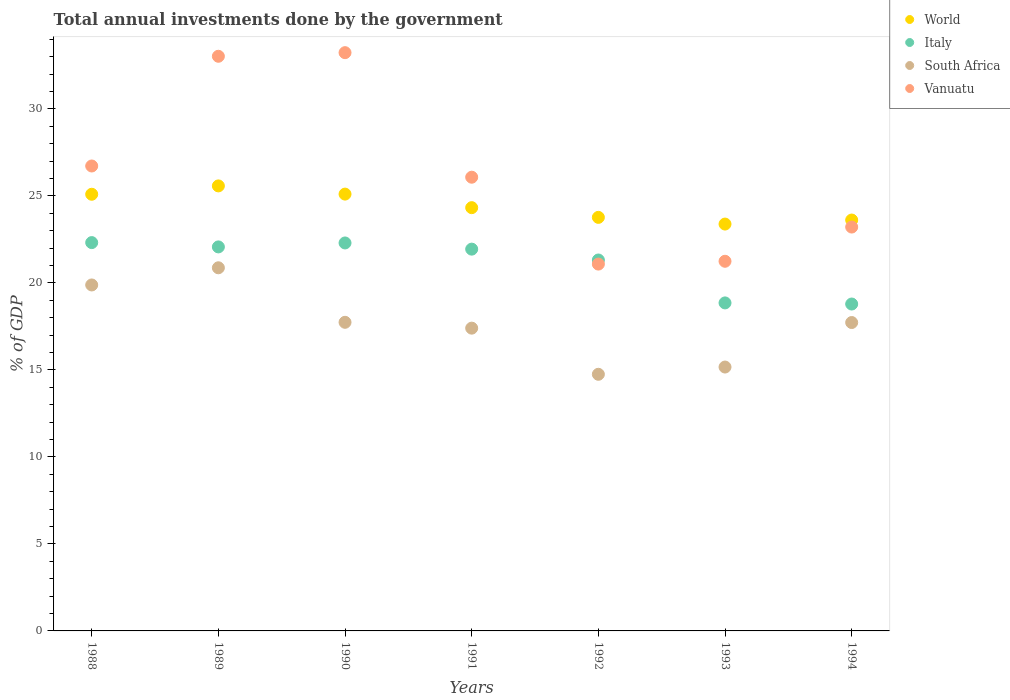How many different coloured dotlines are there?
Your response must be concise. 4. Is the number of dotlines equal to the number of legend labels?
Offer a terse response. Yes. What is the total annual investments done by the government in Vanuatu in 1990?
Provide a succinct answer. 33.23. Across all years, what is the maximum total annual investments done by the government in South Africa?
Give a very brief answer. 20.87. Across all years, what is the minimum total annual investments done by the government in Vanuatu?
Your answer should be compact. 21.08. In which year was the total annual investments done by the government in Italy maximum?
Offer a terse response. 1988. In which year was the total annual investments done by the government in World minimum?
Your answer should be very brief. 1993. What is the total total annual investments done by the government in Vanuatu in the graph?
Provide a succinct answer. 184.56. What is the difference between the total annual investments done by the government in South Africa in 1992 and that in 1993?
Your answer should be compact. -0.42. What is the difference between the total annual investments done by the government in Italy in 1991 and the total annual investments done by the government in World in 1989?
Provide a succinct answer. -3.63. What is the average total annual investments done by the government in Vanuatu per year?
Provide a succinct answer. 26.37. In the year 1990, what is the difference between the total annual investments done by the government in Vanuatu and total annual investments done by the government in South Africa?
Offer a very short reply. 15.49. In how many years, is the total annual investments done by the government in South Africa greater than 20 %?
Offer a very short reply. 1. What is the ratio of the total annual investments done by the government in South Africa in 1988 to that in 1990?
Keep it short and to the point. 1.12. What is the difference between the highest and the second highest total annual investments done by the government in World?
Your answer should be very brief. 0.47. What is the difference between the highest and the lowest total annual investments done by the government in Italy?
Your answer should be compact. 3.53. Is it the case that in every year, the sum of the total annual investments done by the government in Italy and total annual investments done by the government in South Africa  is greater than the sum of total annual investments done by the government in World and total annual investments done by the government in Vanuatu?
Provide a short and direct response. No. How many years are there in the graph?
Offer a very short reply. 7. Does the graph contain grids?
Your response must be concise. No. Where does the legend appear in the graph?
Provide a short and direct response. Top right. What is the title of the graph?
Ensure brevity in your answer.  Total annual investments done by the government. What is the label or title of the X-axis?
Ensure brevity in your answer.  Years. What is the label or title of the Y-axis?
Ensure brevity in your answer.  % of GDP. What is the % of GDP of World in 1988?
Offer a very short reply. 25.09. What is the % of GDP of Italy in 1988?
Ensure brevity in your answer.  22.31. What is the % of GDP in South Africa in 1988?
Your answer should be compact. 19.88. What is the % of GDP of Vanuatu in 1988?
Your answer should be very brief. 26.71. What is the % of GDP in World in 1989?
Give a very brief answer. 25.57. What is the % of GDP of Italy in 1989?
Ensure brevity in your answer.  22.07. What is the % of GDP in South Africa in 1989?
Offer a terse response. 20.87. What is the % of GDP of Vanuatu in 1989?
Provide a short and direct response. 33.02. What is the % of GDP of World in 1990?
Keep it short and to the point. 25.1. What is the % of GDP in Italy in 1990?
Provide a succinct answer. 22.29. What is the % of GDP in South Africa in 1990?
Your answer should be very brief. 17.73. What is the % of GDP of Vanuatu in 1990?
Make the answer very short. 33.23. What is the % of GDP in World in 1991?
Offer a terse response. 24.32. What is the % of GDP in Italy in 1991?
Make the answer very short. 21.94. What is the % of GDP of South Africa in 1991?
Your answer should be compact. 17.4. What is the % of GDP in Vanuatu in 1991?
Ensure brevity in your answer.  26.07. What is the % of GDP in World in 1992?
Your response must be concise. 23.76. What is the % of GDP of Italy in 1992?
Give a very brief answer. 21.31. What is the % of GDP in South Africa in 1992?
Ensure brevity in your answer.  14.75. What is the % of GDP in Vanuatu in 1992?
Offer a very short reply. 21.08. What is the % of GDP in World in 1993?
Give a very brief answer. 23.38. What is the % of GDP in Italy in 1993?
Provide a short and direct response. 18.85. What is the % of GDP of South Africa in 1993?
Make the answer very short. 15.16. What is the % of GDP of Vanuatu in 1993?
Your response must be concise. 21.24. What is the % of GDP in World in 1994?
Offer a very short reply. 23.61. What is the % of GDP in Italy in 1994?
Provide a short and direct response. 18.78. What is the % of GDP in South Africa in 1994?
Your answer should be very brief. 17.72. What is the % of GDP of Vanuatu in 1994?
Offer a very short reply. 23.21. Across all years, what is the maximum % of GDP in World?
Offer a terse response. 25.57. Across all years, what is the maximum % of GDP in Italy?
Your answer should be compact. 22.31. Across all years, what is the maximum % of GDP in South Africa?
Give a very brief answer. 20.87. Across all years, what is the maximum % of GDP of Vanuatu?
Your response must be concise. 33.23. Across all years, what is the minimum % of GDP of World?
Offer a terse response. 23.38. Across all years, what is the minimum % of GDP of Italy?
Ensure brevity in your answer.  18.78. Across all years, what is the minimum % of GDP in South Africa?
Offer a terse response. 14.75. Across all years, what is the minimum % of GDP in Vanuatu?
Make the answer very short. 21.08. What is the total % of GDP of World in the graph?
Offer a very short reply. 170.83. What is the total % of GDP of Italy in the graph?
Make the answer very short. 147.55. What is the total % of GDP in South Africa in the graph?
Make the answer very short. 123.5. What is the total % of GDP of Vanuatu in the graph?
Make the answer very short. 184.56. What is the difference between the % of GDP in World in 1988 and that in 1989?
Keep it short and to the point. -0.48. What is the difference between the % of GDP of Italy in 1988 and that in 1989?
Keep it short and to the point. 0.25. What is the difference between the % of GDP in South Africa in 1988 and that in 1989?
Give a very brief answer. -0.99. What is the difference between the % of GDP of Vanuatu in 1988 and that in 1989?
Your response must be concise. -6.3. What is the difference between the % of GDP of World in 1988 and that in 1990?
Give a very brief answer. -0.01. What is the difference between the % of GDP of Italy in 1988 and that in 1990?
Make the answer very short. 0.02. What is the difference between the % of GDP in South Africa in 1988 and that in 1990?
Your answer should be compact. 2.15. What is the difference between the % of GDP in Vanuatu in 1988 and that in 1990?
Ensure brevity in your answer.  -6.51. What is the difference between the % of GDP of World in 1988 and that in 1991?
Provide a succinct answer. 0.77. What is the difference between the % of GDP of Italy in 1988 and that in 1991?
Provide a succinct answer. 0.38. What is the difference between the % of GDP of South Africa in 1988 and that in 1991?
Provide a succinct answer. 2.48. What is the difference between the % of GDP in Vanuatu in 1988 and that in 1991?
Provide a short and direct response. 0.64. What is the difference between the % of GDP of World in 1988 and that in 1992?
Offer a terse response. 1.33. What is the difference between the % of GDP of South Africa in 1988 and that in 1992?
Make the answer very short. 5.13. What is the difference between the % of GDP of Vanuatu in 1988 and that in 1992?
Make the answer very short. 5.64. What is the difference between the % of GDP in World in 1988 and that in 1993?
Provide a succinct answer. 1.71. What is the difference between the % of GDP in Italy in 1988 and that in 1993?
Your answer should be very brief. 3.47. What is the difference between the % of GDP in South Africa in 1988 and that in 1993?
Your answer should be compact. 4.72. What is the difference between the % of GDP in Vanuatu in 1988 and that in 1993?
Offer a very short reply. 5.47. What is the difference between the % of GDP in World in 1988 and that in 1994?
Keep it short and to the point. 1.48. What is the difference between the % of GDP of Italy in 1988 and that in 1994?
Keep it short and to the point. 3.53. What is the difference between the % of GDP of South Africa in 1988 and that in 1994?
Make the answer very short. 2.16. What is the difference between the % of GDP in Vanuatu in 1988 and that in 1994?
Make the answer very short. 3.51. What is the difference between the % of GDP in World in 1989 and that in 1990?
Give a very brief answer. 0.47. What is the difference between the % of GDP of Italy in 1989 and that in 1990?
Keep it short and to the point. -0.23. What is the difference between the % of GDP of South Africa in 1989 and that in 1990?
Your response must be concise. 3.13. What is the difference between the % of GDP of Vanuatu in 1989 and that in 1990?
Give a very brief answer. -0.21. What is the difference between the % of GDP in World in 1989 and that in 1991?
Keep it short and to the point. 1.25. What is the difference between the % of GDP in Italy in 1989 and that in 1991?
Offer a terse response. 0.13. What is the difference between the % of GDP of South Africa in 1989 and that in 1991?
Keep it short and to the point. 3.47. What is the difference between the % of GDP in Vanuatu in 1989 and that in 1991?
Provide a short and direct response. 6.95. What is the difference between the % of GDP of World in 1989 and that in 1992?
Your response must be concise. 1.81. What is the difference between the % of GDP in Italy in 1989 and that in 1992?
Provide a short and direct response. 0.75. What is the difference between the % of GDP of South Africa in 1989 and that in 1992?
Your answer should be very brief. 6.12. What is the difference between the % of GDP in Vanuatu in 1989 and that in 1992?
Your response must be concise. 11.94. What is the difference between the % of GDP in World in 1989 and that in 1993?
Offer a terse response. 2.19. What is the difference between the % of GDP in Italy in 1989 and that in 1993?
Your answer should be compact. 3.22. What is the difference between the % of GDP of South Africa in 1989 and that in 1993?
Your answer should be compact. 5.7. What is the difference between the % of GDP of Vanuatu in 1989 and that in 1993?
Your answer should be compact. 11.78. What is the difference between the % of GDP of World in 1989 and that in 1994?
Make the answer very short. 1.96. What is the difference between the % of GDP in Italy in 1989 and that in 1994?
Your answer should be compact. 3.28. What is the difference between the % of GDP in South Africa in 1989 and that in 1994?
Your answer should be very brief. 3.15. What is the difference between the % of GDP in Vanuatu in 1989 and that in 1994?
Provide a succinct answer. 9.81. What is the difference between the % of GDP in World in 1990 and that in 1991?
Provide a succinct answer. 0.78. What is the difference between the % of GDP in Italy in 1990 and that in 1991?
Your answer should be compact. 0.36. What is the difference between the % of GDP in South Africa in 1990 and that in 1991?
Offer a very short reply. 0.34. What is the difference between the % of GDP in Vanuatu in 1990 and that in 1991?
Your answer should be compact. 7.16. What is the difference between the % of GDP in World in 1990 and that in 1992?
Your answer should be very brief. 1.34. What is the difference between the % of GDP of Italy in 1990 and that in 1992?
Make the answer very short. 0.98. What is the difference between the % of GDP in South Africa in 1990 and that in 1992?
Provide a short and direct response. 2.99. What is the difference between the % of GDP in Vanuatu in 1990 and that in 1992?
Your response must be concise. 12.15. What is the difference between the % of GDP of World in 1990 and that in 1993?
Provide a short and direct response. 1.72. What is the difference between the % of GDP in Italy in 1990 and that in 1993?
Provide a short and direct response. 3.44. What is the difference between the % of GDP in South Africa in 1990 and that in 1993?
Your answer should be very brief. 2.57. What is the difference between the % of GDP of Vanuatu in 1990 and that in 1993?
Ensure brevity in your answer.  11.99. What is the difference between the % of GDP in World in 1990 and that in 1994?
Give a very brief answer. 1.49. What is the difference between the % of GDP in Italy in 1990 and that in 1994?
Provide a short and direct response. 3.51. What is the difference between the % of GDP in South Africa in 1990 and that in 1994?
Your answer should be compact. 0.01. What is the difference between the % of GDP in Vanuatu in 1990 and that in 1994?
Offer a terse response. 10.02. What is the difference between the % of GDP in World in 1991 and that in 1992?
Ensure brevity in your answer.  0.56. What is the difference between the % of GDP in Italy in 1991 and that in 1992?
Offer a very short reply. 0.62. What is the difference between the % of GDP in South Africa in 1991 and that in 1992?
Offer a very short reply. 2.65. What is the difference between the % of GDP of Vanuatu in 1991 and that in 1992?
Provide a succinct answer. 4.99. What is the difference between the % of GDP of World in 1991 and that in 1993?
Provide a succinct answer. 0.94. What is the difference between the % of GDP in Italy in 1991 and that in 1993?
Keep it short and to the point. 3.09. What is the difference between the % of GDP in South Africa in 1991 and that in 1993?
Make the answer very short. 2.23. What is the difference between the % of GDP of Vanuatu in 1991 and that in 1993?
Make the answer very short. 4.83. What is the difference between the % of GDP in World in 1991 and that in 1994?
Keep it short and to the point. 0.71. What is the difference between the % of GDP of Italy in 1991 and that in 1994?
Your answer should be very brief. 3.15. What is the difference between the % of GDP of South Africa in 1991 and that in 1994?
Your answer should be compact. -0.32. What is the difference between the % of GDP of Vanuatu in 1991 and that in 1994?
Give a very brief answer. 2.86. What is the difference between the % of GDP of World in 1992 and that in 1993?
Ensure brevity in your answer.  0.38. What is the difference between the % of GDP of Italy in 1992 and that in 1993?
Your answer should be compact. 2.47. What is the difference between the % of GDP in South Africa in 1992 and that in 1993?
Offer a terse response. -0.42. What is the difference between the % of GDP in Vanuatu in 1992 and that in 1993?
Give a very brief answer. -0.16. What is the difference between the % of GDP in World in 1992 and that in 1994?
Your response must be concise. 0.15. What is the difference between the % of GDP of Italy in 1992 and that in 1994?
Make the answer very short. 2.53. What is the difference between the % of GDP of South Africa in 1992 and that in 1994?
Provide a short and direct response. -2.97. What is the difference between the % of GDP in Vanuatu in 1992 and that in 1994?
Your answer should be compact. -2.13. What is the difference between the % of GDP in World in 1993 and that in 1994?
Offer a terse response. -0.23. What is the difference between the % of GDP in Italy in 1993 and that in 1994?
Your answer should be compact. 0.06. What is the difference between the % of GDP of South Africa in 1993 and that in 1994?
Provide a short and direct response. -2.56. What is the difference between the % of GDP in Vanuatu in 1993 and that in 1994?
Your answer should be compact. -1.97. What is the difference between the % of GDP in World in 1988 and the % of GDP in Italy in 1989?
Make the answer very short. 3.03. What is the difference between the % of GDP in World in 1988 and the % of GDP in South Africa in 1989?
Give a very brief answer. 4.22. What is the difference between the % of GDP in World in 1988 and the % of GDP in Vanuatu in 1989?
Offer a very short reply. -7.93. What is the difference between the % of GDP in Italy in 1988 and the % of GDP in South Africa in 1989?
Your answer should be very brief. 1.45. What is the difference between the % of GDP in Italy in 1988 and the % of GDP in Vanuatu in 1989?
Your answer should be compact. -10.71. What is the difference between the % of GDP in South Africa in 1988 and the % of GDP in Vanuatu in 1989?
Your answer should be very brief. -13.14. What is the difference between the % of GDP of World in 1988 and the % of GDP of Italy in 1990?
Offer a very short reply. 2.8. What is the difference between the % of GDP in World in 1988 and the % of GDP in South Africa in 1990?
Provide a short and direct response. 7.36. What is the difference between the % of GDP in World in 1988 and the % of GDP in Vanuatu in 1990?
Provide a succinct answer. -8.14. What is the difference between the % of GDP in Italy in 1988 and the % of GDP in South Africa in 1990?
Keep it short and to the point. 4.58. What is the difference between the % of GDP in Italy in 1988 and the % of GDP in Vanuatu in 1990?
Keep it short and to the point. -10.91. What is the difference between the % of GDP in South Africa in 1988 and the % of GDP in Vanuatu in 1990?
Give a very brief answer. -13.35. What is the difference between the % of GDP of World in 1988 and the % of GDP of Italy in 1991?
Ensure brevity in your answer.  3.15. What is the difference between the % of GDP in World in 1988 and the % of GDP in South Africa in 1991?
Give a very brief answer. 7.69. What is the difference between the % of GDP in World in 1988 and the % of GDP in Vanuatu in 1991?
Offer a terse response. -0.98. What is the difference between the % of GDP in Italy in 1988 and the % of GDP in South Africa in 1991?
Offer a terse response. 4.92. What is the difference between the % of GDP of Italy in 1988 and the % of GDP of Vanuatu in 1991?
Provide a short and direct response. -3.76. What is the difference between the % of GDP of South Africa in 1988 and the % of GDP of Vanuatu in 1991?
Your answer should be compact. -6.19. What is the difference between the % of GDP of World in 1988 and the % of GDP of Italy in 1992?
Make the answer very short. 3.78. What is the difference between the % of GDP of World in 1988 and the % of GDP of South Africa in 1992?
Your answer should be very brief. 10.34. What is the difference between the % of GDP of World in 1988 and the % of GDP of Vanuatu in 1992?
Your answer should be compact. 4.01. What is the difference between the % of GDP of Italy in 1988 and the % of GDP of South Africa in 1992?
Your answer should be very brief. 7.57. What is the difference between the % of GDP in Italy in 1988 and the % of GDP in Vanuatu in 1992?
Keep it short and to the point. 1.23. What is the difference between the % of GDP in South Africa in 1988 and the % of GDP in Vanuatu in 1992?
Ensure brevity in your answer.  -1.2. What is the difference between the % of GDP of World in 1988 and the % of GDP of Italy in 1993?
Provide a succinct answer. 6.24. What is the difference between the % of GDP of World in 1988 and the % of GDP of South Africa in 1993?
Your answer should be compact. 9.93. What is the difference between the % of GDP of World in 1988 and the % of GDP of Vanuatu in 1993?
Give a very brief answer. 3.85. What is the difference between the % of GDP in Italy in 1988 and the % of GDP in South Africa in 1993?
Keep it short and to the point. 7.15. What is the difference between the % of GDP in Italy in 1988 and the % of GDP in Vanuatu in 1993?
Offer a very short reply. 1.07. What is the difference between the % of GDP in South Africa in 1988 and the % of GDP in Vanuatu in 1993?
Your answer should be very brief. -1.36. What is the difference between the % of GDP in World in 1988 and the % of GDP in Italy in 1994?
Offer a very short reply. 6.31. What is the difference between the % of GDP of World in 1988 and the % of GDP of South Africa in 1994?
Offer a very short reply. 7.37. What is the difference between the % of GDP in World in 1988 and the % of GDP in Vanuatu in 1994?
Keep it short and to the point. 1.88. What is the difference between the % of GDP in Italy in 1988 and the % of GDP in South Africa in 1994?
Provide a succinct answer. 4.59. What is the difference between the % of GDP of Italy in 1988 and the % of GDP of Vanuatu in 1994?
Make the answer very short. -0.89. What is the difference between the % of GDP in South Africa in 1988 and the % of GDP in Vanuatu in 1994?
Provide a succinct answer. -3.33. What is the difference between the % of GDP in World in 1989 and the % of GDP in Italy in 1990?
Keep it short and to the point. 3.28. What is the difference between the % of GDP of World in 1989 and the % of GDP of South Africa in 1990?
Offer a terse response. 7.84. What is the difference between the % of GDP in World in 1989 and the % of GDP in Vanuatu in 1990?
Offer a terse response. -7.66. What is the difference between the % of GDP in Italy in 1989 and the % of GDP in South Africa in 1990?
Give a very brief answer. 4.33. What is the difference between the % of GDP in Italy in 1989 and the % of GDP in Vanuatu in 1990?
Your response must be concise. -11.16. What is the difference between the % of GDP of South Africa in 1989 and the % of GDP of Vanuatu in 1990?
Give a very brief answer. -12.36. What is the difference between the % of GDP of World in 1989 and the % of GDP of Italy in 1991?
Offer a terse response. 3.63. What is the difference between the % of GDP in World in 1989 and the % of GDP in South Africa in 1991?
Make the answer very short. 8.17. What is the difference between the % of GDP of World in 1989 and the % of GDP of Vanuatu in 1991?
Make the answer very short. -0.5. What is the difference between the % of GDP in Italy in 1989 and the % of GDP in South Africa in 1991?
Provide a short and direct response. 4.67. What is the difference between the % of GDP in Italy in 1989 and the % of GDP in Vanuatu in 1991?
Your answer should be compact. -4. What is the difference between the % of GDP of South Africa in 1989 and the % of GDP of Vanuatu in 1991?
Offer a very short reply. -5.2. What is the difference between the % of GDP in World in 1989 and the % of GDP in Italy in 1992?
Your answer should be very brief. 4.26. What is the difference between the % of GDP in World in 1989 and the % of GDP in South Africa in 1992?
Ensure brevity in your answer.  10.82. What is the difference between the % of GDP in World in 1989 and the % of GDP in Vanuatu in 1992?
Provide a short and direct response. 4.49. What is the difference between the % of GDP in Italy in 1989 and the % of GDP in South Africa in 1992?
Your answer should be compact. 7.32. What is the difference between the % of GDP of Italy in 1989 and the % of GDP of Vanuatu in 1992?
Make the answer very short. 0.99. What is the difference between the % of GDP in South Africa in 1989 and the % of GDP in Vanuatu in 1992?
Keep it short and to the point. -0.21. What is the difference between the % of GDP in World in 1989 and the % of GDP in Italy in 1993?
Your answer should be compact. 6.72. What is the difference between the % of GDP of World in 1989 and the % of GDP of South Africa in 1993?
Offer a terse response. 10.41. What is the difference between the % of GDP of World in 1989 and the % of GDP of Vanuatu in 1993?
Your response must be concise. 4.33. What is the difference between the % of GDP in Italy in 1989 and the % of GDP in South Africa in 1993?
Provide a succinct answer. 6.9. What is the difference between the % of GDP in Italy in 1989 and the % of GDP in Vanuatu in 1993?
Ensure brevity in your answer.  0.83. What is the difference between the % of GDP in South Africa in 1989 and the % of GDP in Vanuatu in 1993?
Provide a short and direct response. -0.37. What is the difference between the % of GDP in World in 1989 and the % of GDP in Italy in 1994?
Provide a succinct answer. 6.79. What is the difference between the % of GDP of World in 1989 and the % of GDP of South Africa in 1994?
Offer a terse response. 7.85. What is the difference between the % of GDP of World in 1989 and the % of GDP of Vanuatu in 1994?
Keep it short and to the point. 2.36. What is the difference between the % of GDP in Italy in 1989 and the % of GDP in South Africa in 1994?
Provide a succinct answer. 4.35. What is the difference between the % of GDP in Italy in 1989 and the % of GDP in Vanuatu in 1994?
Provide a succinct answer. -1.14. What is the difference between the % of GDP of South Africa in 1989 and the % of GDP of Vanuatu in 1994?
Keep it short and to the point. -2.34. What is the difference between the % of GDP in World in 1990 and the % of GDP in Italy in 1991?
Keep it short and to the point. 3.16. What is the difference between the % of GDP of World in 1990 and the % of GDP of South Africa in 1991?
Offer a very short reply. 7.7. What is the difference between the % of GDP of World in 1990 and the % of GDP of Vanuatu in 1991?
Your response must be concise. -0.97. What is the difference between the % of GDP in Italy in 1990 and the % of GDP in South Africa in 1991?
Keep it short and to the point. 4.9. What is the difference between the % of GDP in Italy in 1990 and the % of GDP in Vanuatu in 1991?
Make the answer very short. -3.78. What is the difference between the % of GDP of South Africa in 1990 and the % of GDP of Vanuatu in 1991?
Provide a short and direct response. -8.34. What is the difference between the % of GDP in World in 1990 and the % of GDP in Italy in 1992?
Your answer should be compact. 3.79. What is the difference between the % of GDP in World in 1990 and the % of GDP in South Africa in 1992?
Ensure brevity in your answer.  10.35. What is the difference between the % of GDP of World in 1990 and the % of GDP of Vanuatu in 1992?
Ensure brevity in your answer.  4.02. What is the difference between the % of GDP of Italy in 1990 and the % of GDP of South Africa in 1992?
Give a very brief answer. 7.55. What is the difference between the % of GDP of Italy in 1990 and the % of GDP of Vanuatu in 1992?
Make the answer very short. 1.21. What is the difference between the % of GDP in South Africa in 1990 and the % of GDP in Vanuatu in 1992?
Offer a terse response. -3.35. What is the difference between the % of GDP in World in 1990 and the % of GDP in Italy in 1993?
Offer a terse response. 6.25. What is the difference between the % of GDP of World in 1990 and the % of GDP of South Africa in 1993?
Provide a succinct answer. 9.94. What is the difference between the % of GDP of World in 1990 and the % of GDP of Vanuatu in 1993?
Make the answer very short. 3.86. What is the difference between the % of GDP of Italy in 1990 and the % of GDP of South Africa in 1993?
Ensure brevity in your answer.  7.13. What is the difference between the % of GDP in Italy in 1990 and the % of GDP in Vanuatu in 1993?
Offer a terse response. 1.05. What is the difference between the % of GDP of South Africa in 1990 and the % of GDP of Vanuatu in 1993?
Your response must be concise. -3.51. What is the difference between the % of GDP in World in 1990 and the % of GDP in Italy in 1994?
Offer a terse response. 6.32. What is the difference between the % of GDP of World in 1990 and the % of GDP of South Africa in 1994?
Make the answer very short. 7.38. What is the difference between the % of GDP in World in 1990 and the % of GDP in Vanuatu in 1994?
Give a very brief answer. 1.89. What is the difference between the % of GDP in Italy in 1990 and the % of GDP in South Africa in 1994?
Keep it short and to the point. 4.57. What is the difference between the % of GDP in Italy in 1990 and the % of GDP in Vanuatu in 1994?
Keep it short and to the point. -0.91. What is the difference between the % of GDP in South Africa in 1990 and the % of GDP in Vanuatu in 1994?
Your answer should be very brief. -5.47. What is the difference between the % of GDP of World in 1991 and the % of GDP of Italy in 1992?
Offer a terse response. 3.01. What is the difference between the % of GDP of World in 1991 and the % of GDP of South Africa in 1992?
Keep it short and to the point. 9.57. What is the difference between the % of GDP of World in 1991 and the % of GDP of Vanuatu in 1992?
Offer a terse response. 3.24. What is the difference between the % of GDP of Italy in 1991 and the % of GDP of South Africa in 1992?
Ensure brevity in your answer.  7.19. What is the difference between the % of GDP of Italy in 1991 and the % of GDP of Vanuatu in 1992?
Your answer should be very brief. 0.86. What is the difference between the % of GDP of South Africa in 1991 and the % of GDP of Vanuatu in 1992?
Your answer should be very brief. -3.68. What is the difference between the % of GDP in World in 1991 and the % of GDP in Italy in 1993?
Ensure brevity in your answer.  5.47. What is the difference between the % of GDP in World in 1991 and the % of GDP in South Africa in 1993?
Provide a succinct answer. 9.16. What is the difference between the % of GDP of World in 1991 and the % of GDP of Vanuatu in 1993?
Your answer should be very brief. 3.08. What is the difference between the % of GDP in Italy in 1991 and the % of GDP in South Africa in 1993?
Your answer should be compact. 6.78. What is the difference between the % of GDP of Italy in 1991 and the % of GDP of Vanuatu in 1993?
Your answer should be compact. 0.7. What is the difference between the % of GDP in South Africa in 1991 and the % of GDP in Vanuatu in 1993?
Offer a terse response. -3.84. What is the difference between the % of GDP in World in 1991 and the % of GDP in Italy in 1994?
Your answer should be compact. 5.54. What is the difference between the % of GDP in World in 1991 and the % of GDP in South Africa in 1994?
Your response must be concise. 6.6. What is the difference between the % of GDP in World in 1991 and the % of GDP in Vanuatu in 1994?
Give a very brief answer. 1.11. What is the difference between the % of GDP in Italy in 1991 and the % of GDP in South Africa in 1994?
Offer a terse response. 4.22. What is the difference between the % of GDP in Italy in 1991 and the % of GDP in Vanuatu in 1994?
Give a very brief answer. -1.27. What is the difference between the % of GDP in South Africa in 1991 and the % of GDP in Vanuatu in 1994?
Ensure brevity in your answer.  -5.81. What is the difference between the % of GDP in World in 1992 and the % of GDP in Italy in 1993?
Your answer should be compact. 4.92. What is the difference between the % of GDP in World in 1992 and the % of GDP in South Africa in 1993?
Make the answer very short. 8.6. What is the difference between the % of GDP in World in 1992 and the % of GDP in Vanuatu in 1993?
Your response must be concise. 2.52. What is the difference between the % of GDP of Italy in 1992 and the % of GDP of South Africa in 1993?
Provide a succinct answer. 6.15. What is the difference between the % of GDP of Italy in 1992 and the % of GDP of Vanuatu in 1993?
Your response must be concise. 0.07. What is the difference between the % of GDP in South Africa in 1992 and the % of GDP in Vanuatu in 1993?
Your response must be concise. -6.49. What is the difference between the % of GDP in World in 1992 and the % of GDP in Italy in 1994?
Your response must be concise. 4.98. What is the difference between the % of GDP in World in 1992 and the % of GDP in South Africa in 1994?
Offer a very short reply. 6.04. What is the difference between the % of GDP in World in 1992 and the % of GDP in Vanuatu in 1994?
Your response must be concise. 0.56. What is the difference between the % of GDP of Italy in 1992 and the % of GDP of South Africa in 1994?
Ensure brevity in your answer.  3.59. What is the difference between the % of GDP of Italy in 1992 and the % of GDP of Vanuatu in 1994?
Your answer should be very brief. -1.89. What is the difference between the % of GDP in South Africa in 1992 and the % of GDP in Vanuatu in 1994?
Make the answer very short. -8.46. What is the difference between the % of GDP of World in 1993 and the % of GDP of Italy in 1994?
Ensure brevity in your answer.  4.59. What is the difference between the % of GDP of World in 1993 and the % of GDP of South Africa in 1994?
Provide a succinct answer. 5.66. What is the difference between the % of GDP in World in 1993 and the % of GDP in Vanuatu in 1994?
Keep it short and to the point. 0.17. What is the difference between the % of GDP of Italy in 1993 and the % of GDP of South Africa in 1994?
Provide a short and direct response. 1.13. What is the difference between the % of GDP of Italy in 1993 and the % of GDP of Vanuatu in 1994?
Offer a very short reply. -4.36. What is the difference between the % of GDP of South Africa in 1993 and the % of GDP of Vanuatu in 1994?
Offer a terse response. -8.04. What is the average % of GDP of World per year?
Your answer should be very brief. 24.4. What is the average % of GDP in Italy per year?
Make the answer very short. 21.08. What is the average % of GDP of South Africa per year?
Your answer should be compact. 17.64. What is the average % of GDP in Vanuatu per year?
Provide a succinct answer. 26.37. In the year 1988, what is the difference between the % of GDP of World and % of GDP of Italy?
Make the answer very short. 2.78. In the year 1988, what is the difference between the % of GDP of World and % of GDP of South Africa?
Offer a terse response. 5.21. In the year 1988, what is the difference between the % of GDP in World and % of GDP in Vanuatu?
Offer a very short reply. -1.62. In the year 1988, what is the difference between the % of GDP of Italy and % of GDP of South Africa?
Offer a terse response. 2.43. In the year 1988, what is the difference between the % of GDP of Italy and % of GDP of Vanuatu?
Offer a terse response. -4.4. In the year 1988, what is the difference between the % of GDP of South Africa and % of GDP of Vanuatu?
Give a very brief answer. -6.84. In the year 1989, what is the difference between the % of GDP of World and % of GDP of Italy?
Your answer should be compact. 3.51. In the year 1989, what is the difference between the % of GDP in World and % of GDP in South Africa?
Give a very brief answer. 4.71. In the year 1989, what is the difference between the % of GDP in World and % of GDP in Vanuatu?
Offer a terse response. -7.45. In the year 1989, what is the difference between the % of GDP of Italy and % of GDP of South Africa?
Keep it short and to the point. 1.2. In the year 1989, what is the difference between the % of GDP of Italy and % of GDP of Vanuatu?
Your answer should be very brief. -10.95. In the year 1989, what is the difference between the % of GDP of South Africa and % of GDP of Vanuatu?
Offer a terse response. -12.15. In the year 1990, what is the difference between the % of GDP of World and % of GDP of Italy?
Keep it short and to the point. 2.81. In the year 1990, what is the difference between the % of GDP in World and % of GDP in South Africa?
Keep it short and to the point. 7.37. In the year 1990, what is the difference between the % of GDP of World and % of GDP of Vanuatu?
Offer a terse response. -8.13. In the year 1990, what is the difference between the % of GDP in Italy and % of GDP in South Africa?
Your response must be concise. 4.56. In the year 1990, what is the difference between the % of GDP in Italy and % of GDP in Vanuatu?
Offer a terse response. -10.93. In the year 1990, what is the difference between the % of GDP of South Africa and % of GDP of Vanuatu?
Your answer should be very brief. -15.49. In the year 1991, what is the difference between the % of GDP of World and % of GDP of Italy?
Make the answer very short. 2.38. In the year 1991, what is the difference between the % of GDP in World and % of GDP in South Africa?
Ensure brevity in your answer.  6.92. In the year 1991, what is the difference between the % of GDP of World and % of GDP of Vanuatu?
Ensure brevity in your answer.  -1.75. In the year 1991, what is the difference between the % of GDP of Italy and % of GDP of South Africa?
Your answer should be very brief. 4.54. In the year 1991, what is the difference between the % of GDP of Italy and % of GDP of Vanuatu?
Ensure brevity in your answer.  -4.13. In the year 1991, what is the difference between the % of GDP in South Africa and % of GDP in Vanuatu?
Provide a short and direct response. -8.67. In the year 1992, what is the difference between the % of GDP in World and % of GDP in Italy?
Ensure brevity in your answer.  2.45. In the year 1992, what is the difference between the % of GDP of World and % of GDP of South Africa?
Keep it short and to the point. 9.02. In the year 1992, what is the difference between the % of GDP in World and % of GDP in Vanuatu?
Offer a terse response. 2.68. In the year 1992, what is the difference between the % of GDP in Italy and % of GDP in South Africa?
Provide a succinct answer. 6.57. In the year 1992, what is the difference between the % of GDP of Italy and % of GDP of Vanuatu?
Ensure brevity in your answer.  0.24. In the year 1992, what is the difference between the % of GDP of South Africa and % of GDP of Vanuatu?
Ensure brevity in your answer.  -6.33. In the year 1993, what is the difference between the % of GDP in World and % of GDP in Italy?
Make the answer very short. 4.53. In the year 1993, what is the difference between the % of GDP of World and % of GDP of South Africa?
Offer a terse response. 8.22. In the year 1993, what is the difference between the % of GDP in World and % of GDP in Vanuatu?
Offer a very short reply. 2.14. In the year 1993, what is the difference between the % of GDP in Italy and % of GDP in South Africa?
Your response must be concise. 3.69. In the year 1993, what is the difference between the % of GDP in Italy and % of GDP in Vanuatu?
Keep it short and to the point. -2.39. In the year 1993, what is the difference between the % of GDP in South Africa and % of GDP in Vanuatu?
Make the answer very short. -6.08. In the year 1994, what is the difference between the % of GDP of World and % of GDP of Italy?
Your answer should be very brief. 4.83. In the year 1994, what is the difference between the % of GDP of World and % of GDP of South Africa?
Offer a very short reply. 5.89. In the year 1994, what is the difference between the % of GDP in World and % of GDP in Vanuatu?
Your response must be concise. 0.4. In the year 1994, what is the difference between the % of GDP in Italy and % of GDP in South Africa?
Offer a very short reply. 1.06. In the year 1994, what is the difference between the % of GDP in Italy and % of GDP in Vanuatu?
Provide a succinct answer. -4.42. In the year 1994, what is the difference between the % of GDP of South Africa and % of GDP of Vanuatu?
Offer a very short reply. -5.49. What is the ratio of the % of GDP in World in 1988 to that in 1989?
Give a very brief answer. 0.98. What is the ratio of the % of GDP in Italy in 1988 to that in 1989?
Give a very brief answer. 1.01. What is the ratio of the % of GDP in South Africa in 1988 to that in 1989?
Your response must be concise. 0.95. What is the ratio of the % of GDP in Vanuatu in 1988 to that in 1989?
Keep it short and to the point. 0.81. What is the ratio of the % of GDP of World in 1988 to that in 1990?
Your answer should be very brief. 1. What is the ratio of the % of GDP in South Africa in 1988 to that in 1990?
Your answer should be very brief. 1.12. What is the ratio of the % of GDP of Vanuatu in 1988 to that in 1990?
Offer a very short reply. 0.8. What is the ratio of the % of GDP of World in 1988 to that in 1991?
Ensure brevity in your answer.  1.03. What is the ratio of the % of GDP of Italy in 1988 to that in 1991?
Keep it short and to the point. 1.02. What is the ratio of the % of GDP in South Africa in 1988 to that in 1991?
Give a very brief answer. 1.14. What is the ratio of the % of GDP in Vanuatu in 1988 to that in 1991?
Give a very brief answer. 1.02. What is the ratio of the % of GDP in World in 1988 to that in 1992?
Provide a succinct answer. 1.06. What is the ratio of the % of GDP of Italy in 1988 to that in 1992?
Your answer should be compact. 1.05. What is the ratio of the % of GDP of South Africa in 1988 to that in 1992?
Provide a succinct answer. 1.35. What is the ratio of the % of GDP in Vanuatu in 1988 to that in 1992?
Give a very brief answer. 1.27. What is the ratio of the % of GDP in World in 1988 to that in 1993?
Ensure brevity in your answer.  1.07. What is the ratio of the % of GDP of Italy in 1988 to that in 1993?
Your answer should be compact. 1.18. What is the ratio of the % of GDP of South Africa in 1988 to that in 1993?
Give a very brief answer. 1.31. What is the ratio of the % of GDP of Vanuatu in 1988 to that in 1993?
Offer a very short reply. 1.26. What is the ratio of the % of GDP of World in 1988 to that in 1994?
Provide a short and direct response. 1.06. What is the ratio of the % of GDP of Italy in 1988 to that in 1994?
Provide a short and direct response. 1.19. What is the ratio of the % of GDP in South Africa in 1988 to that in 1994?
Keep it short and to the point. 1.12. What is the ratio of the % of GDP in Vanuatu in 1988 to that in 1994?
Keep it short and to the point. 1.15. What is the ratio of the % of GDP in World in 1989 to that in 1990?
Keep it short and to the point. 1.02. What is the ratio of the % of GDP of Italy in 1989 to that in 1990?
Provide a short and direct response. 0.99. What is the ratio of the % of GDP of South Africa in 1989 to that in 1990?
Provide a succinct answer. 1.18. What is the ratio of the % of GDP of World in 1989 to that in 1991?
Provide a succinct answer. 1.05. What is the ratio of the % of GDP in South Africa in 1989 to that in 1991?
Give a very brief answer. 1.2. What is the ratio of the % of GDP of Vanuatu in 1989 to that in 1991?
Your answer should be compact. 1.27. What is the ratio of the % of GDP in World in 1989 to that in 1992?
Provide a succinct answer. 1.08. What is the ratio of the % of GDP in Italy in 1989 to that in 1992?
Keep it short and to the point. 1.04. What is the ratio of the % of GDP of South Africa in 1989 to that in 1992?
Your response must be concise. 1.42. What is the ratio of the % of GDP in Vanuatu in 1989 to that in 1992?
Provide a succinct answer. 1.57. What is the ratio of the % of GDP in World in 1989 to that in 1993?
Provide a succinct answer. 1.09. What is the ratio of the % of GDP of Italy in 1989 to that in 1993?
Your answer should be compact. 1.17. What is the ratio of the % of GDP in South Africa in 1989 to that in 1993?
Offer a terse response. 1.38. What is the ratio of the % of GDP in Vanuatu in 1989 to that in 1993?
Keep it short and to the point. 1.55. What is the ratio of the % of GDP of World in 1989 to that in 1994?
Your answer should be compact. 1.08. What is the ratio of the % of GDP in Italy in 1989 to that in 1994?
Keep it short and to the point. 1.17. What is the ratio of the % of GDP in South Africa in 1989 to that in 1994?
Provide a succinct answer. 1.18. What is the ratio of the % of GDP of Vanuatu in 1989 to that in 1994?
Your answer should be very brief. 1.42. What is the ratio of the % of GDP of World in 1990 to that in 1991?
Make the answer very short. 1.03. What is the ratio of the % of GDP in Italy in 1990 to that in 1991?
Offer a very short reply. 1.02. What is the ratio of the % of GDP of South Africa in 1990 to that in 1991?
Your response must be concise. 1.02. What is the ratio of the % of GDP of Vanuatu in 1990 to that in 1991?
Offer a very short reply. 1.27. What is the ratio of the % of GDP in World in 1990 to that in 1992?
Give a very brief answer. 1.06. What is the ratio of the % of GDP of Italy in 1990 to that in 1992?
Give a very brief answer. 1.05. What is the ratio of the % of GDP in South Africa in 1990 to that in 1992?
Provide a short and direct response. 1.2. What is the ratio of the % of GDP in Vanuatu in 1990 to that in 1992?
Keep it short and to the point. 1.58. What is the ratio of the % of GDP in World in 1990 to that in 1993?
Provide a short and direct response. 1.07. What is the ratio of the % of GDP in Italy in 1990 to that in 1993?
Keep it short and to the point. 1.18. What is the ratio of the % of GDP of South Africa in 1990 to that in 1993?
Provide a short and direct response. 1.17. What is the ratio of the % of GDP in Vanuatu in 1990 to that in 1993?
Offer a terse response. 1.56. What is the ratio of the % of GDP in World in 1990 to that in 1994?
Provide a short and direct response. 1.06. What is the ratio of the % of GDP in Italy in 1990 to that in 1994?
Your response must be concise. 1.19. What is the ratio of the % of GDP of South Africa in 1990 to that in 1994?
Provide a short and direct response. 1. What is the ratio of the % of GDP in Vanuatu in 1990 to that in 1994?
Your response must be concise. 1.43. What is the ratio of the % of GDP of World in 1991 to that in 1992?
Provide a short and direct response. 1.02. What is the ratio of the % of GDP in Italy in 1991 to that in 1992?
Provide a short and direct response. 1.03. What is the ratio of the % of GDP of South Africa in 1991 to that in 1992?
Provide a succinct answer. 1.18. What is the ratio of the % of GDP of Vanuatu in 1991 to that in 1992?
Your answer should be very brief. 1.24. What is the ratio of the % of GDP in World in 1991 to that in 1993?
Offer a terse response. 1.04. What is the ratio of the % of GDP in Italy in 1991 to that in 1993?
Make the answer very short. 1.16. What is the ratio of the % of GDP of South Africa in 1991 to that in 1993?
Provide a short and direct response. 1.15. What is the ratio of the % of GDP of Vanuatu in 1991 to that in 1993?
Your response must be concise. 1.23. What is the ratio of the % of GDP of World in 1991 to that in 1994?
Provide a succinct answer. 1.03. What is the ratio of the % of GDP in Italy in 1991 to that in 1994?
Your response must be concise. 1.17. What is the ratio of the % of GDP of South Africa in 1991 to that in 1994?
Ensure brevity in your answer.  0.98. What is the ratio of the % of GDP in Vanuatu in 1991 to that in 1994?
Your response must be concise. 1.12. What is the ratio of the % of GDP of World in 1992 to that in 1993?
Your answer should be very brief. 1.02. What is the ratio of the % of GDP of Italy in 1992 to that in 1993?
Offer a very short reply. 1.13. What is the ratio of the % of GDP of South Africa in 1992 to that in 1993?
Offer a terse response. 0.97. What is the ratio of the % of GDP of Vanuatu in 1992 to that in 1993?
Provide a short and direct response. 0.99. What is the ratio of the % of GDP of Italy in 1992 to that in 1994?
Your response must be concise. 1.13. What is the ratio of the % of GDP of South Africa in 1992 to that in 1994?
Your answer should be compact. 0.83. What is the ratio of the % of GDP of Vanuatu in 1992 to that in 1994?
Your answer should be very brief. 0.91. What is the ratio of the % of GDP in World in 1993 to that in 1994?
Your answer should be compact. 0.99. What is the ratio of the % of GDP in South Africa in 1993 to that in 1994?
Provide a short and direct response. 0.86. What is the ratio of the % of GDP in Vanuatu in 1993 to that in 1994?
Offer a very short reply. 0.92. What is the difference between the highest and the second highest % of GDP in World?
Your response must be concise. 0.47. What is the difference between the highest and the second highest % of GDP in Italy?
Provide a short and direct response. 0.02. What is the difference between the highest and the second highest % of GDP of South Africa?
Give a very brief answer. 0.99. What is the difference between the highest and the second highest % of GDP in Vanuatu?
Give a very brief answer. 0.21. What is the difference between the highest and the lowest % of GDP of World?
Make the answer very short. 2.19. What is the difference between the highest and the lowest % of GDP of Italy?
Your response must be concise. 3.53. What is the difference between the highest and the lowest % of GDP of South Africa?
Offer a very short reply. 6.12. What is the difference between the highest and the lowest % of GDP of Vanuatu?
Offer a very short reply. 12.15. 